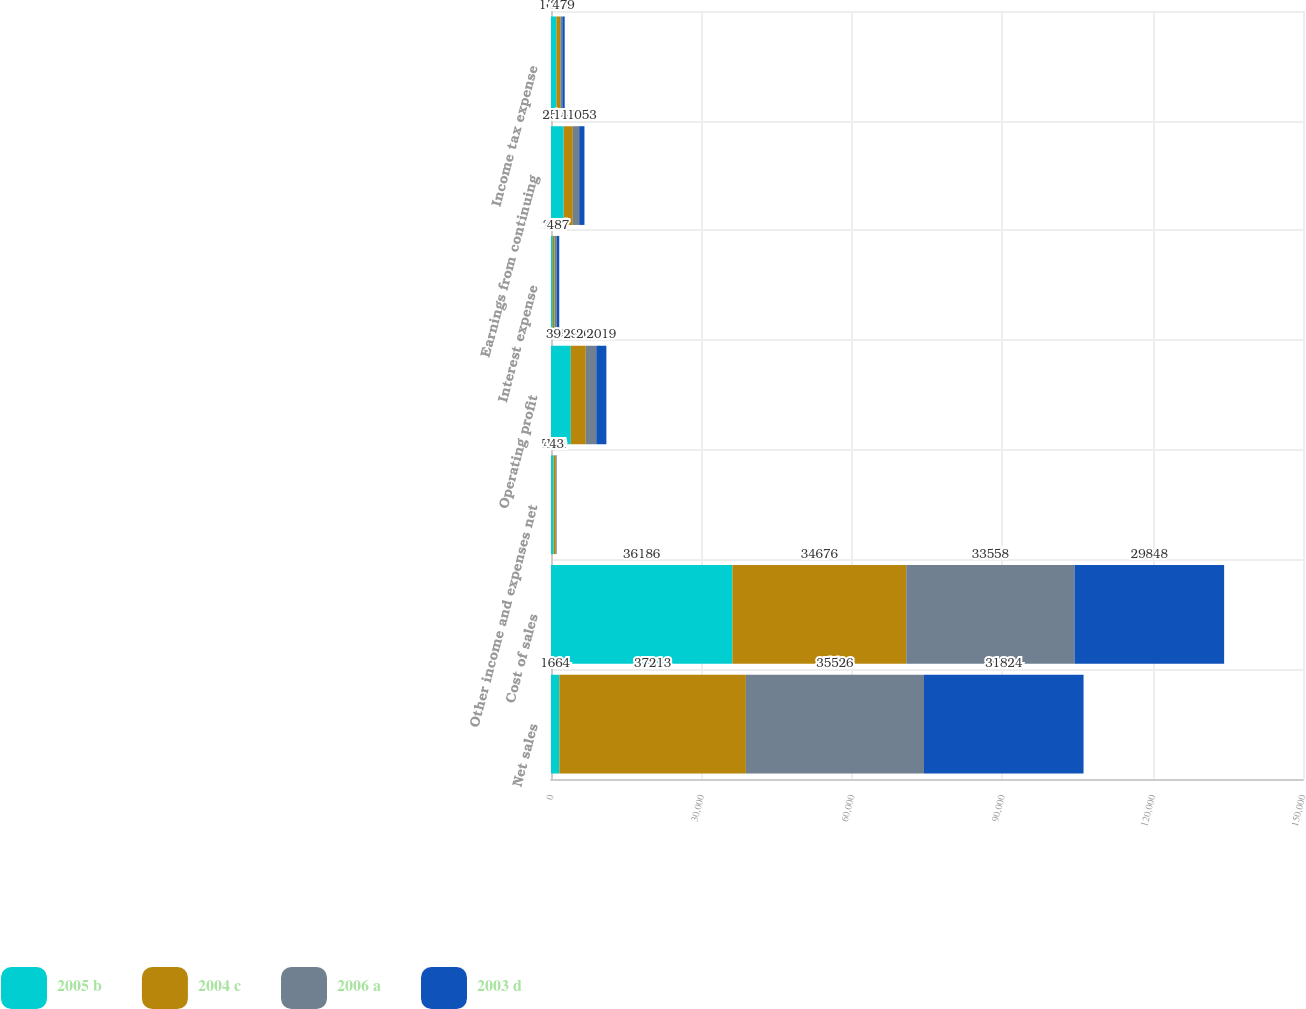Convert chart to OTSL. <chart><loc_0><loc_0><loc_500><loc_500><stacked_bar_chart><ecel><fcel>Net sales<fcel>Cost of sales<fcel>Other income and expenses net<fcel>Operating profit<fcel>Interest expense<fcel>Earnings from continuing<fcel>Income tax expense<nl><fcel>2005 b<fcel>1664<fcel>36186<fcel>519<fcel>3953<fcel>361<fcel>2529<fcel>1063<nl><fcel>2004 c<fcel>37213<fcel>34676<fcel>449<fcel>2986<fcel>370<fcel>1825<fcel>791<nl><fcel>2006 a<fcel>35526<fcel>33558<fcel>121<fcel>2089<fcel>425<fcel>1266<fcel>398<nl><fcel>2003 d<fcel>31824<fcel>29848<fcel>43<fcel>2019<fcel>487<fcel>1053<fcel>479<nl></chart> 